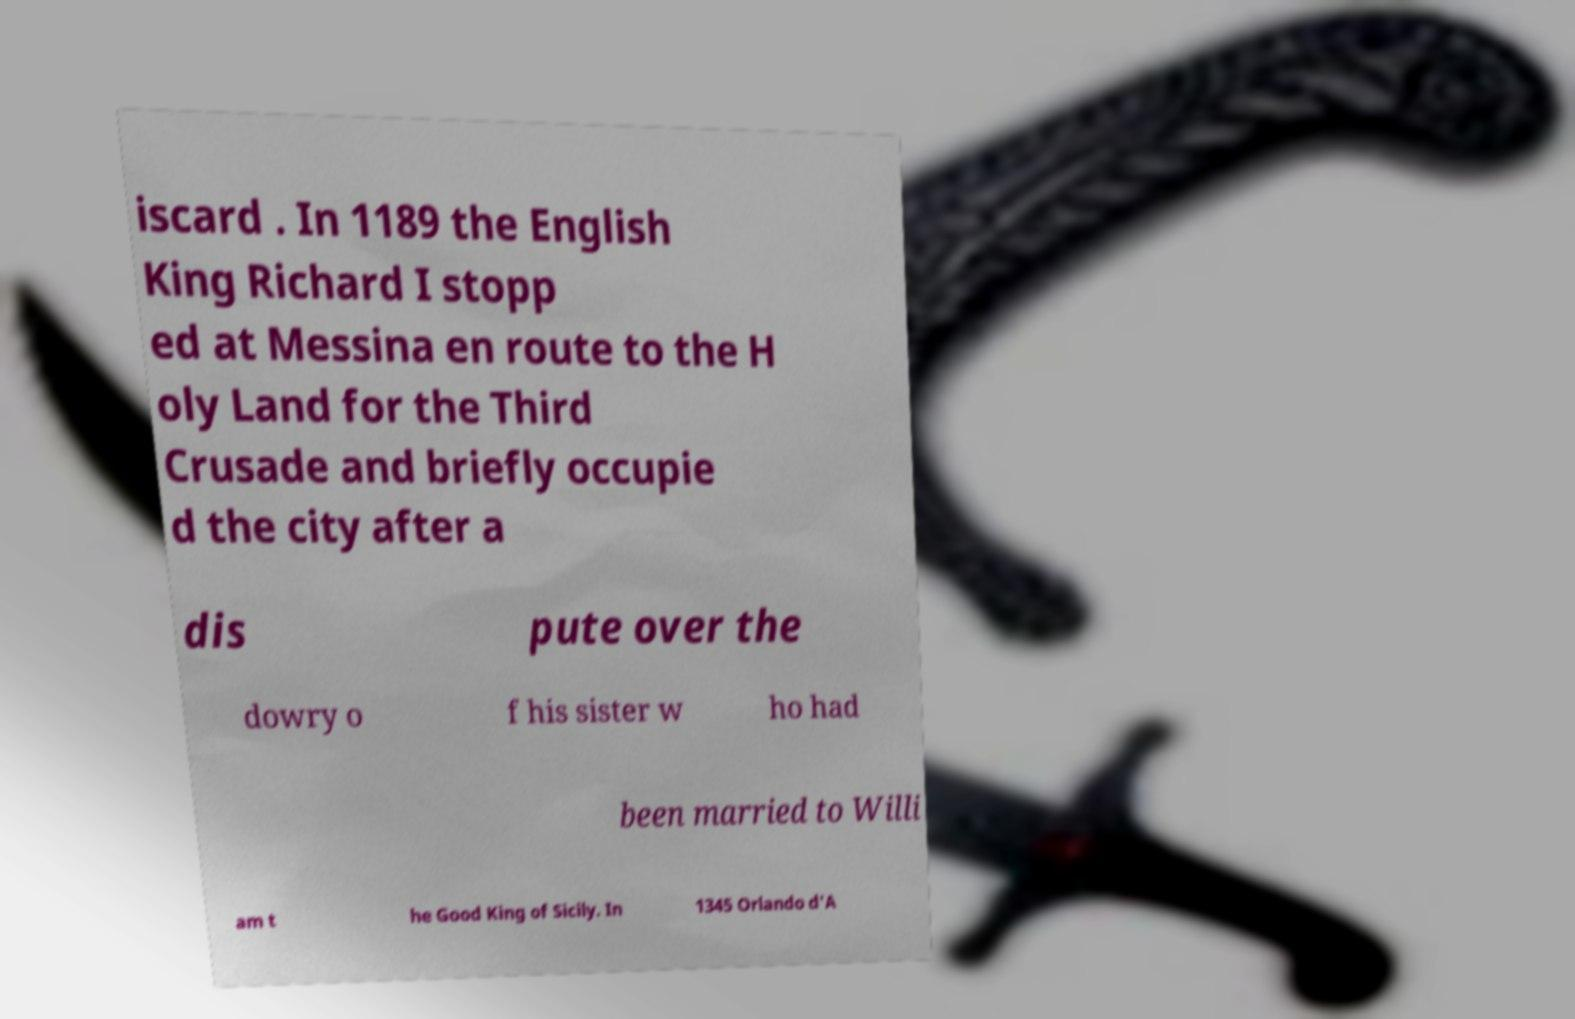I need the written content from this picture converted into text. Can you do that? iscard . In 1189 the English King Richard I stopp ed at Messina en route to the H oly Land for the Third Crusade and briefly occupie d the city after a dis pute over the dowry o f his sister w ho had been married to Willi am t he Good King of Sicily. In 1345 Orlando d'A 